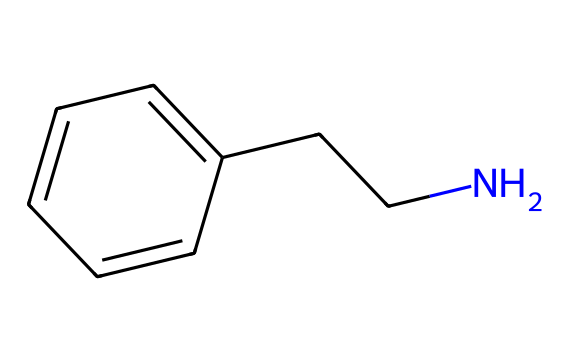What is the molecular formula for this compound? By examining the structure of phenylethylamine, we can identify the atoms present. It consists of carbon (C), hydrogen (H), and nitrogen (N). Counting the carbon atoms gives us 8 (the aromatic ring plus the side chain), the hydrogen atoms total to 11, and there is 1 nitrogen atom, leading to the molecular formula C8H11N.
Answer: C8H11N How many rings are present in this chemical structure? Analyzing the structure reveals that it contains 1 aromatic ring, which can be identified by the alternating double bonds within the cyclic arrangement of carbon atoms.
Answer: 1 What type of amine is phenylethylamine? The structure shows that phenylethylamine has a primary amine functional group, as the nitrogen is bonded to one alkyl chain (C-C) and not to any additional nitrogen atoms. This indicates its classification as a primary amine.
Answer: primary Does this compound have any chiral centers? Reviewing the structure, we observe that none of the carbon atoms are bonded to four different substituents, which indicates that there are no chiral centers present.
Answer: no What feature causes phenylethylamine to potentially improve mood? The presence of the nitrogen atom in the structure suggests it acts as a neurotransmitter or neuromodulator, which can influence mood regulation mechanisms in the brain.
Answer: nitrogen How does the structure of phenylethylamine relate to its classification as an organometallic? The classification as an organometallic compound is based on the presence of carbon-based molecules that can interact with metals. However, phenylethylamine itself does not involve metal directly but can influence metal-interacting compounds.
Answer: involves carbon but not metal 